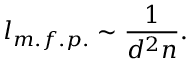<formula> <loc_0><loc_0><loc_500><loc_500>l _ { m . f . p . } \sim \frac { 1 } { d ^ { 2 } n } .</formula> 